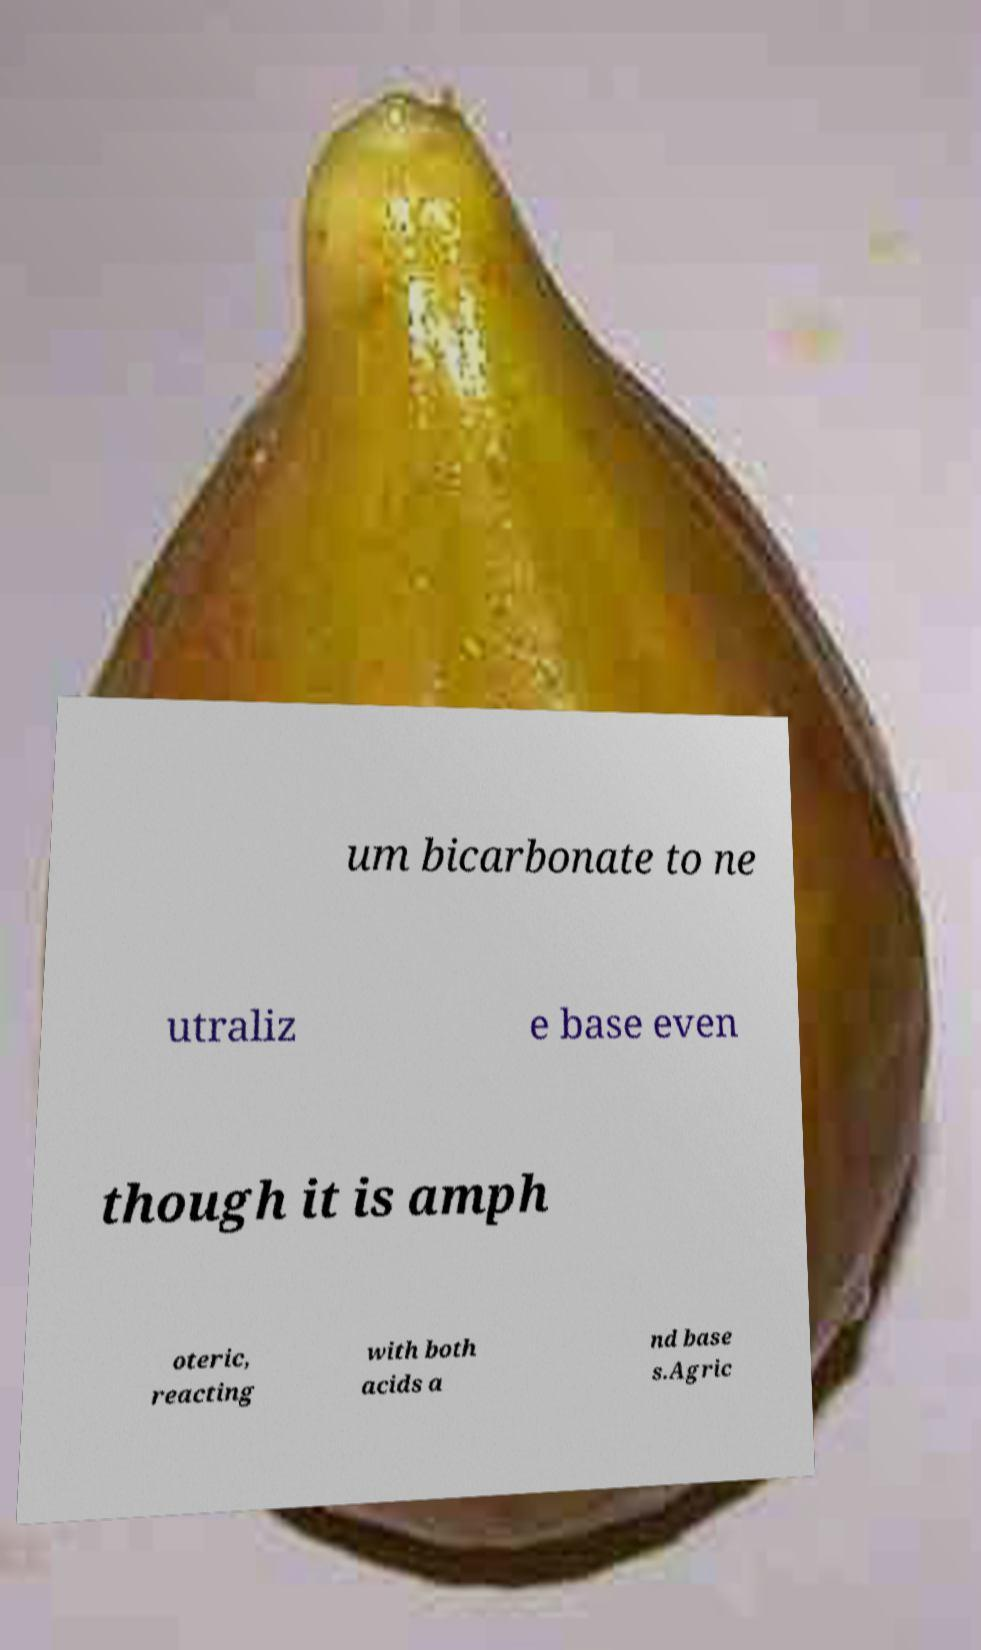There's text embedded in this image that I need extracted. Can you transcribe it verbatim? um bicarbonate to ne utraliz e base even though it is amph oteric, reacting with both acids a nd base s.Agric 